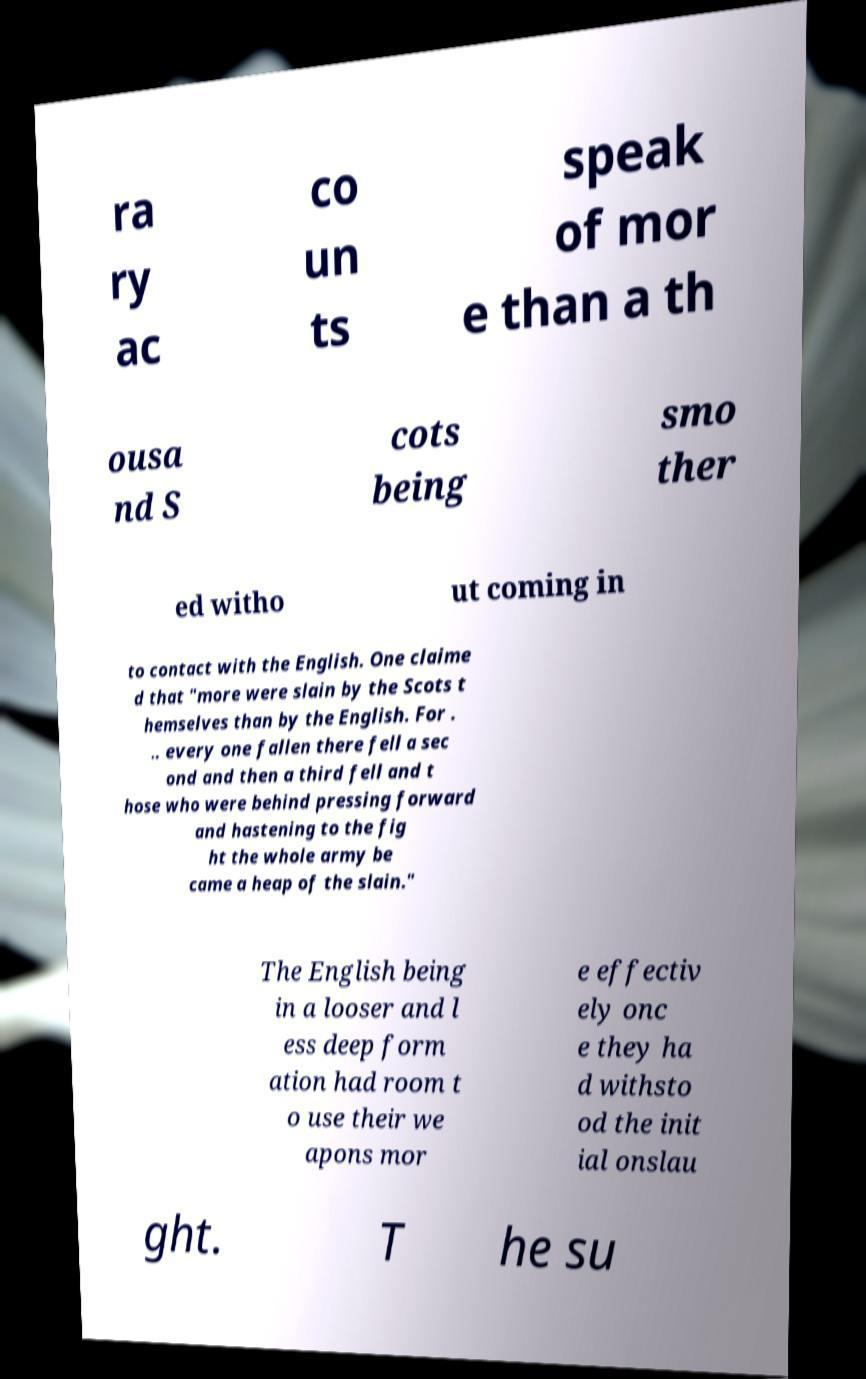What messages or text are displayed in this image? I need them in a readable, typed format. ra ry ac co un ts speak of mor e than a th ousa nd S cots being smo ther ed witho ut coming in to contact with the English. One claime d that "more were slain by the Scots t hemselves than by the English. For . .. every one fallen there fell a sec ond and then a third fell and t hose who were behind pressing forward and hastening to the fig ht the whole army be came a heap of the slain." The English being in a looser and l ess deep form ation had room t o use their we apons mor e effectiv ely onc e they ha d withsto od the init ial onslau ght. T he su 